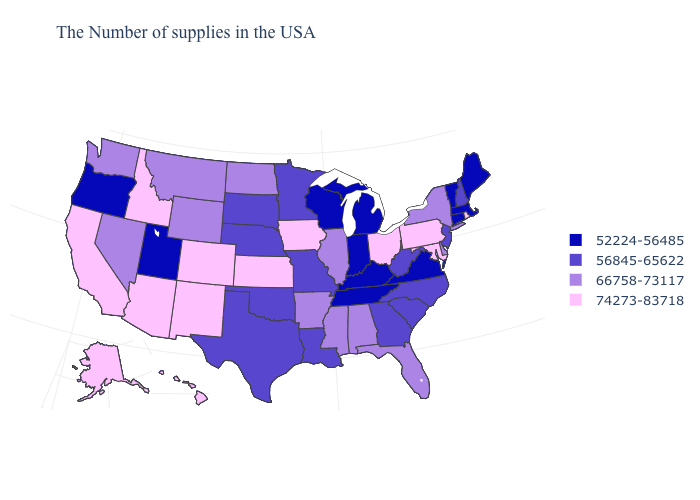Among the states that border Pennsylvania , does New Jersey have the highest value?
Give a very brief answer. No. What is the value of Oklahoma?
Keep it brief. 56845-65622. What is the lowest value in the Northeast?
Answer briefly. 52224-56485. What is the value of Pennsylvania?
Be succinct. 74273-83718. How many symbols are there in the legend?
Write a very short answer. 4. Among the states that border Illinois , which have the highest value?
Give a very brief answer. Iowa. Does Rhode Island have the highest value in the USA?
Quick response, please. Yes. Does Nevada have the highest value in the USA?
Keep it brief. No. Among the states that border Louisiana , does Mississippi have the lowest value?
Short answer required. No. What is the value of Wisconsin?
Write a very short answer. 52224-56485. Does Rhode Island have the lowest value in the USA?
Be succinct. No. Among the states that border Delaware , does Maryland have the lowest value?
Short answer required. No. Among the states that border New Mexico , does Colorado have the highest value?
Concise answer only. Yes. Does Texas have the same value as South Carolina?
Keep it brief. Yes. Name the states that have a value in the range 56845-65622?
Concise answer only. New Hampshire, New Jersey, North Carolina, South Carolina, West Virginia, Georgia, Louisiana, Missouri, Minnesota, Nebraska, Oklahoma, Texas, South Dakota. 